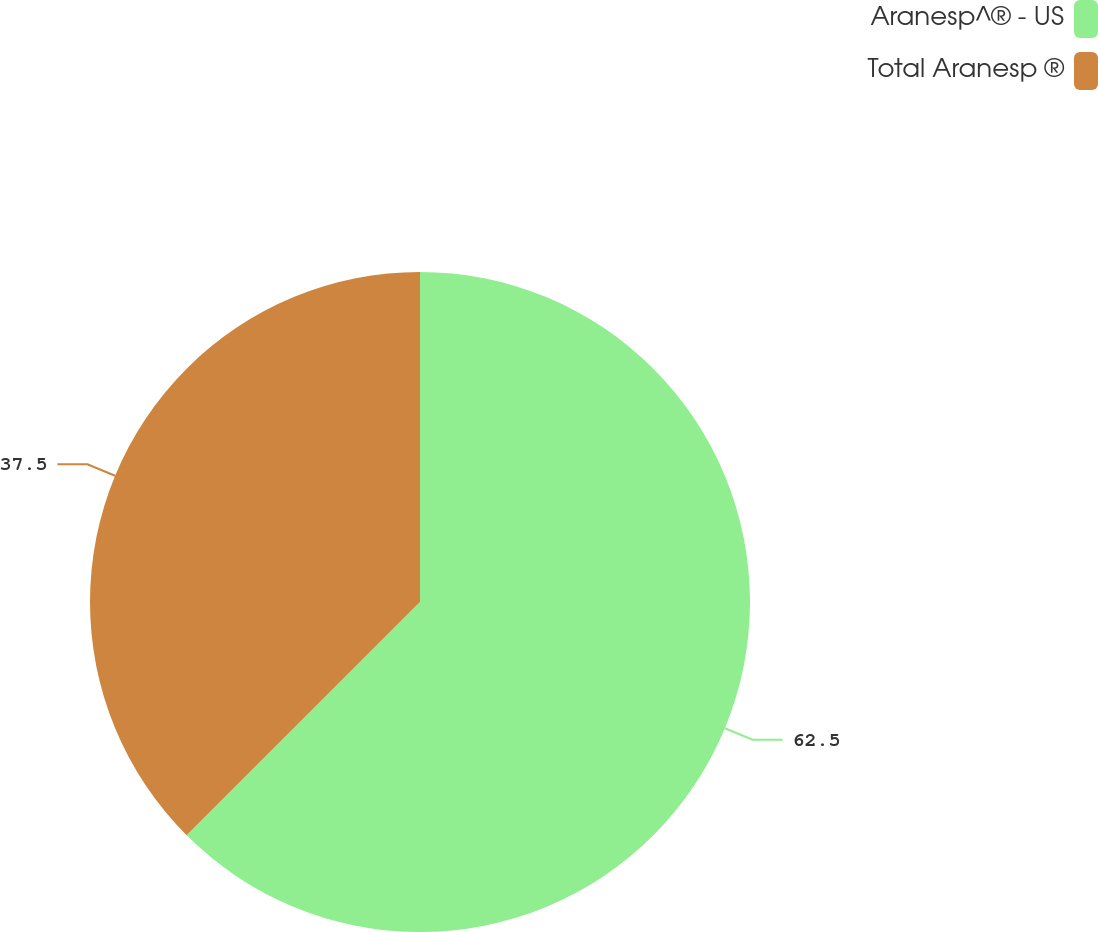Convert chart. <chart><loc_0><loc_0><loc_500><loc_500><pie_chart><fcel>Aranesp^® - US<fcel>Total Aranesp ®<nl><fcel>62.5%<fcel>37.5%<nl></chart> 